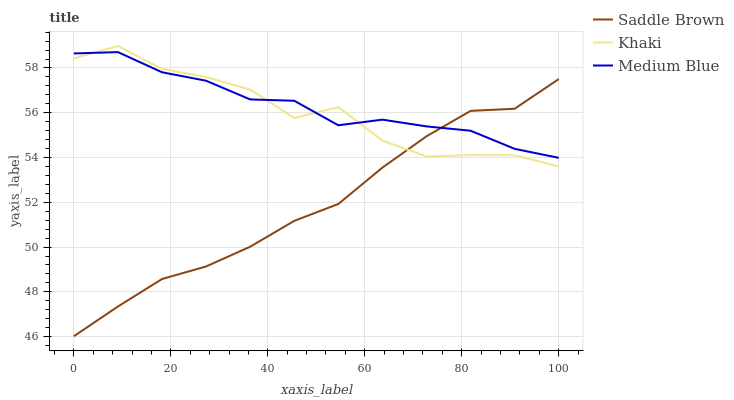Does Saddle Brown have the minimum area under the curve?
Answer yes or no. Yes. Does Medium Blue have the maximum area under the curve?
Answer yes or no. Yes. Does Medium Blue have the minimum area under the curve?
Answer yes or no. No. Does Saddle Brown have the maximum area under the curve?
Answer yes or no. No. Is Saddle Brown the smoothest?
Answer yes or no. Yes. Is Khaki the roughest?
Answer yes or no. Yes. Is Medium Blue the smoothest?
Answer yes or no. No. Is Medium Blue the roughest?
Answer yes or no. No. Does Medium Blue have the lowest value?
Answer yes or no. No. Does Khaki have the highest value?
Answer yes or no. Yes. Does Medium Blue have the highest value?
Answer yes or no. No. Does Medium Blue intersect Saddle Brown?
Answer yes or no. Yes. Is Medium Blue less than Saddle Brown?
Answer yes or no. No. Is Medium Blue greater than Saddle Brown?
Answer yes or no. No. 